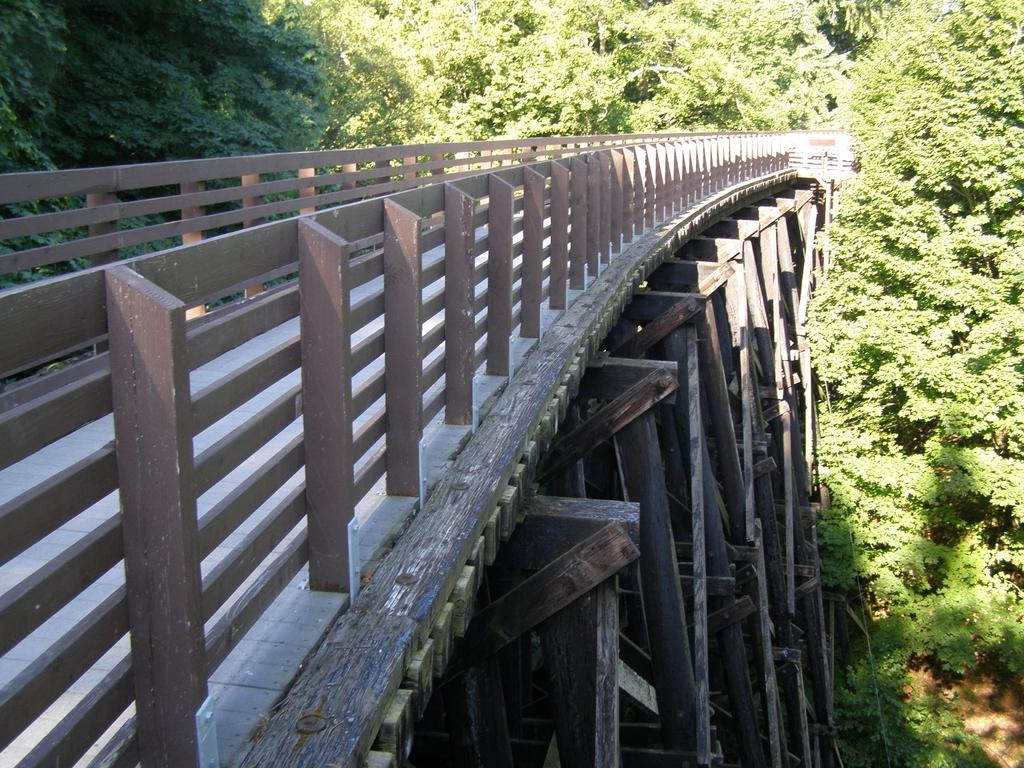What type of structure is present in the image? There is a wooden bridge in the image. What can be seen around the wooden bridge? There are trees surrounding the wooden bridge. How many rabbits can be seen hopping on the wooden bridge in the image? There are no rabbits present in the image; it only features a wooden bridge surrounded by trees. What type of net is used to catch fish in the image? There is no net or fishing activity depicted in the image; it only shows a wooden bridge and trees. 